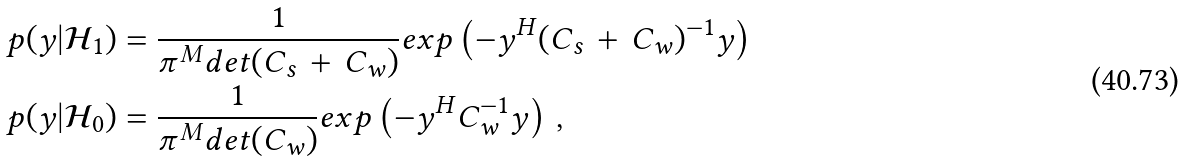<formula> <loc_0><loc_0><loc_500><loc_500>p ( y | \mathcal { H } _ { 1 } ) & = \frac { 1 } { \pi ^ { M } d e t ( C _ { s } \, + \, C _ { w } ) } e x p \left ( - y ^ { H } ( C _ { s } \, + \, C _ { w } ) ^ { - 1 } y \right ) \\ p ( y | \mathcal { H } _ { 0 } ) & = \frac { 1 } { \pi ^ { M } d e t ( C _ { w } ) } e x p \left ( - y ^ { H } C _ { w } ^ { - 1 } y \right ) \, ,</formula> 